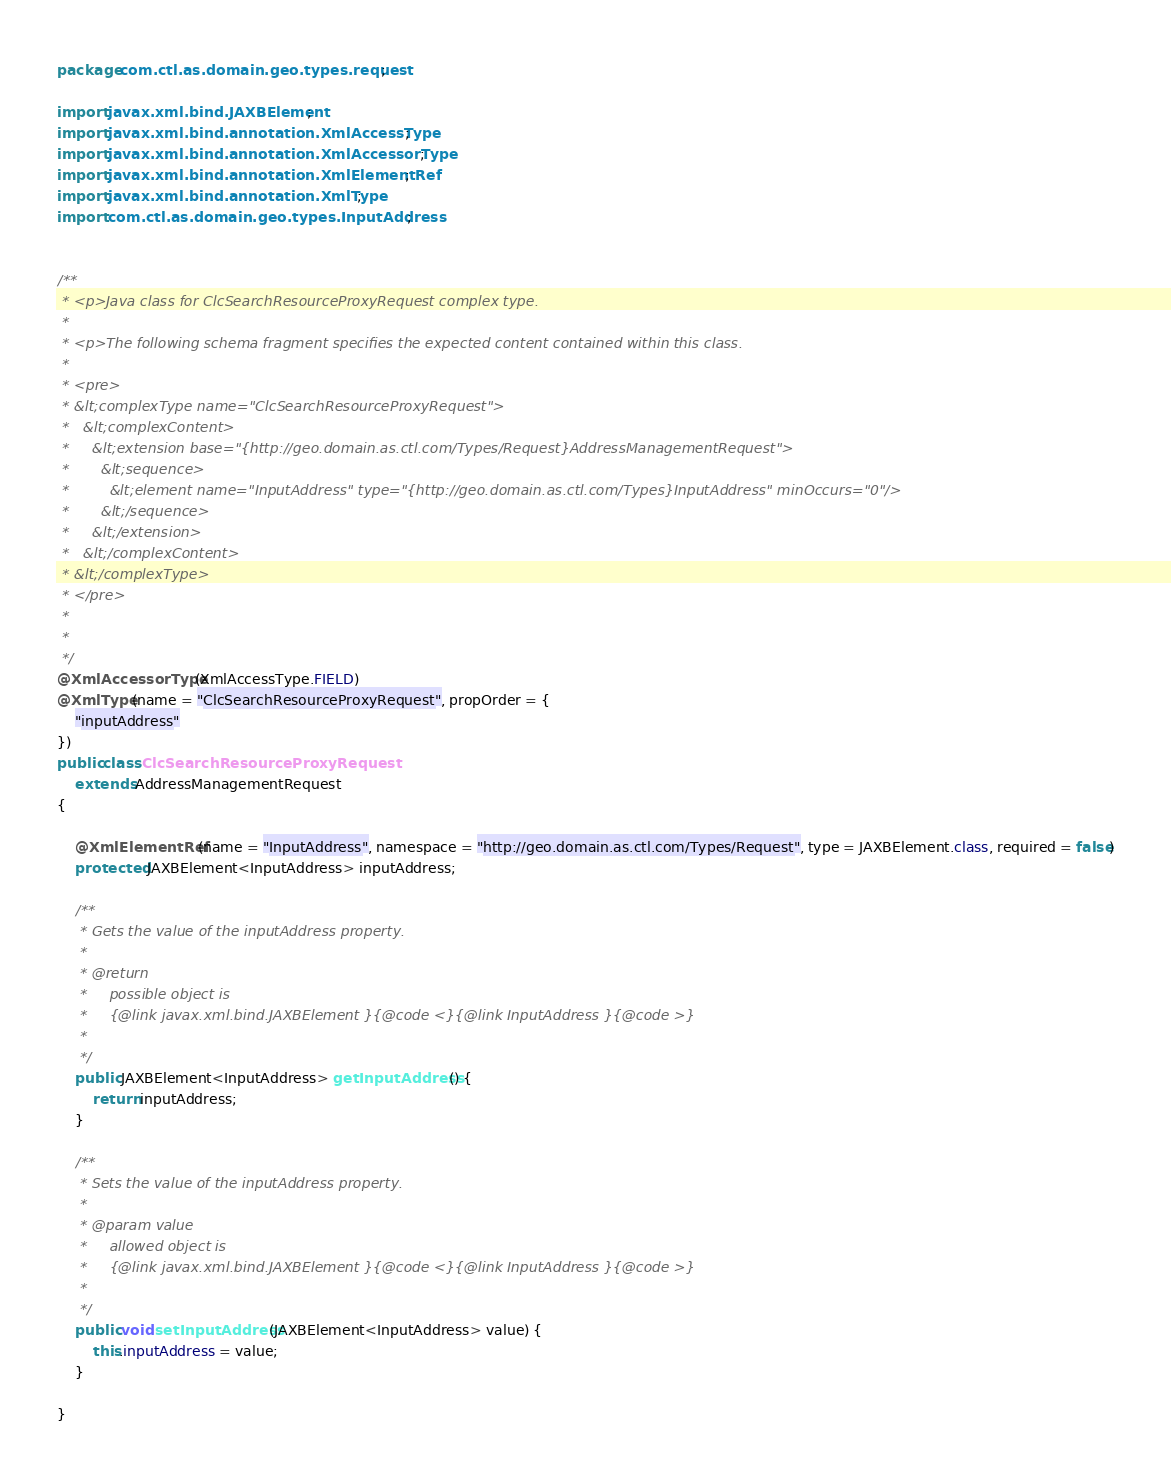<code> <loc_0><loc_0><loc_500><loc_500><_Java_>
package com.ctl.as.domain.geo.types.request;

import javax.xml.bind.JAXBElement;
import javax.xml.bind.annotation.XmlAccessType;
import javax.xml.bind.annotation.XmlAccessorType;
import javax.xml.bind.annotation.XmlElementRef;
import javax.xml.bind.annotation.XmlType;
import com.ctl.as.domain.geo.types.InputAddress;


/**
 * <p>Java class for ClcSearchResourceProxyRequest complex type.
 *
 * <p>The following schema fragment specifies the expected content contained within this class.
 *
 * <pre>
 * &lt;complexType name="ClcSearchResourceProxyRequest">
 *   &lt;complexContent>
 *     &lt;extension base="{http://geo.domain.as.ctl.com/Types/Request}AddressManagementRequest">
 *       &lt;sequence>
 *         &lt;element name="InputAddress" type="{http://geo.domain.as.ctl.com/Types}InputAddress" minOccurs="0"/>
 *       &lt;/sequence>
 *     &lt;/extension>
 *   &lt;/complexContent>
 * &lt;/complexType>
 * </pre>
 *
 *
 */
@XmlAccessorType(XmlAccessType.FIELD)
@XmlType(name = "ClcSearchResourceProxyRequest", propOrder = {
    "inputAddress"
})
public class ClcSearchResourceProxyRequest
    extends AddressManagementRequest
{

    @XmlElementRef(name = "InputAddress", namespace = "http://geo.domain.as.ctl.com/Types/Request", type = JAXBElement.class, required = false)
    protected JAXBElement<InputAddress> inputAddress;

    /**
     * Gets the value of the inputAddress property.
     *
     * @return
     *     possible object is
     *     {@link javax.xml.bind.JAXBElement }{@code <}{@link InputAddress }{@code >}
     *
     */
    public JAXBElement<InputAddress> getInputAddress() {
        return inputAddress;
    }

    /**
     * Sets the value of the inputAddress property.
     *
     * @param value
     *     allowed object is
     *     {@link javax.xml.bind.JAXBElement }{@code <}{@link InputAddress }{@code >}
     *
     */
    public void setInputAddress(JAXBElement<InputAddress> value) {
        this.inputAddress = value;
    }

}
</code> 